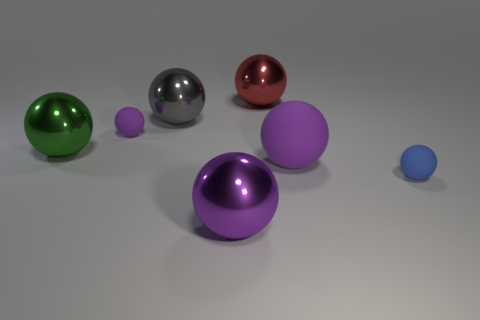Are there more rubber things that are left of the large gray shiny thing than big gray things on the right side of the small blue sphere?
Make the answer very short. Yes. What number of other objects are there of the same size as the purple metal ball?
Keep it short and to the point. 4. There is a small purple rubber object; does it have the same shape as the big object that is behind the big gray shiny object?
Offer a terse response. Yes. What number of rubber objects are either big purple cubes or blue balls?
Make the answer very short. 1. Is there another big rubber sphere that has the same color as the big rubber sphere?
Give a very brief answer. No. Are any purple spheres visible?
Keep it short and to the point. Yes. How many small things are either red shiny objects or blue metallic objects?
Give a very brief answer. 0. What color is the large matte sphere?
Offer a terse response. Purple. There is a large thing that is to the left of the tiny thing left of the blue rubber ball; what is its shape?
Ensure brevity in your answer.  Sphere. Is there another small ball that has the same material as the tiny blue ball?
Provide a short and direct response. Yes. 